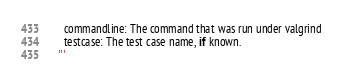<code> <loc_0><loc_0><loc_500><loc_500><_Python_>      commandline: The command that was run under valgrind
      testcase: The test case name, if known.
    '''
</code> 